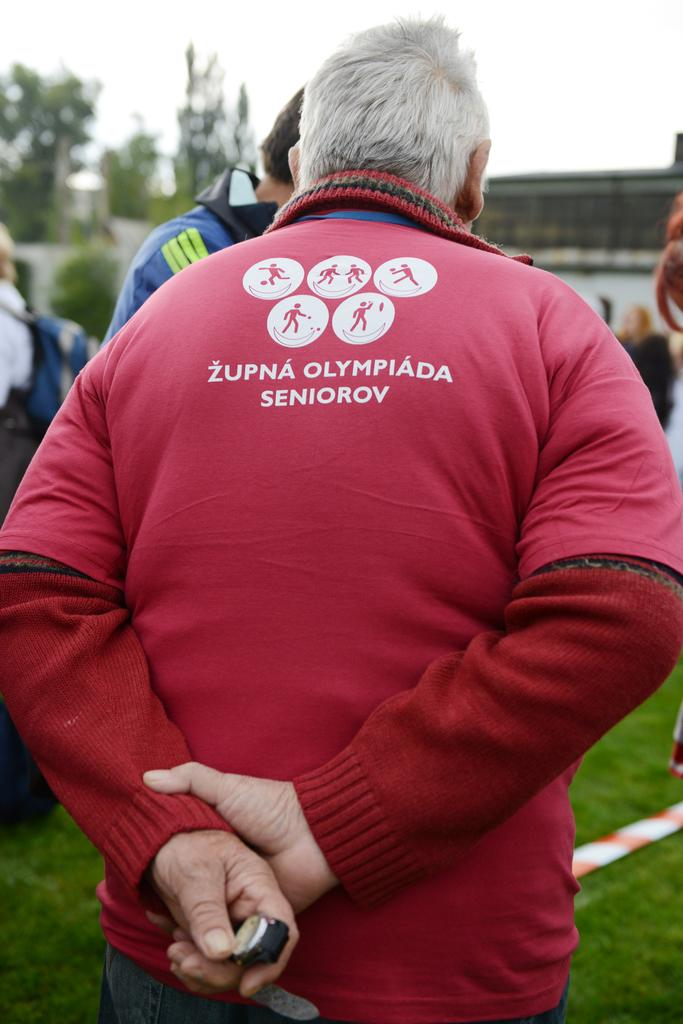What are the people in the image doing? There are people standing in the image, but their specific actions are not mentioned. Can you describe any specific object held by one of the people? Yes, there is a person holding a watch in the image. What type of natural environment is visible in the image? There is green grass visible in the image, and there are also trees present. What type of cart can be seen in the image? There is no cart present in the image. How does the person holding the watch express their feelings towards the trees in the image? The person's feelings towards the trees are not mentioned in the image, so it cannot be determined. 